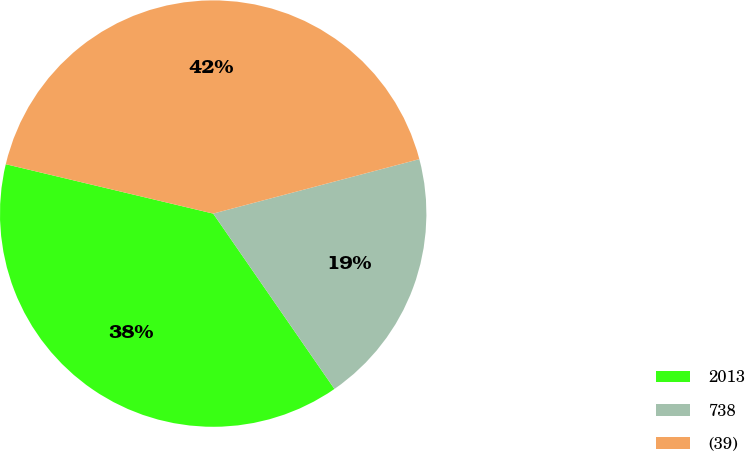<chart> <loc_0><loc_0><loc_500><loc_500><pie_chart><fcel>2013<fcel>738<fcel>(39)<nl><fcel>38.35%<fcel>19.48%<fcel>42.17%<nl></chart> 